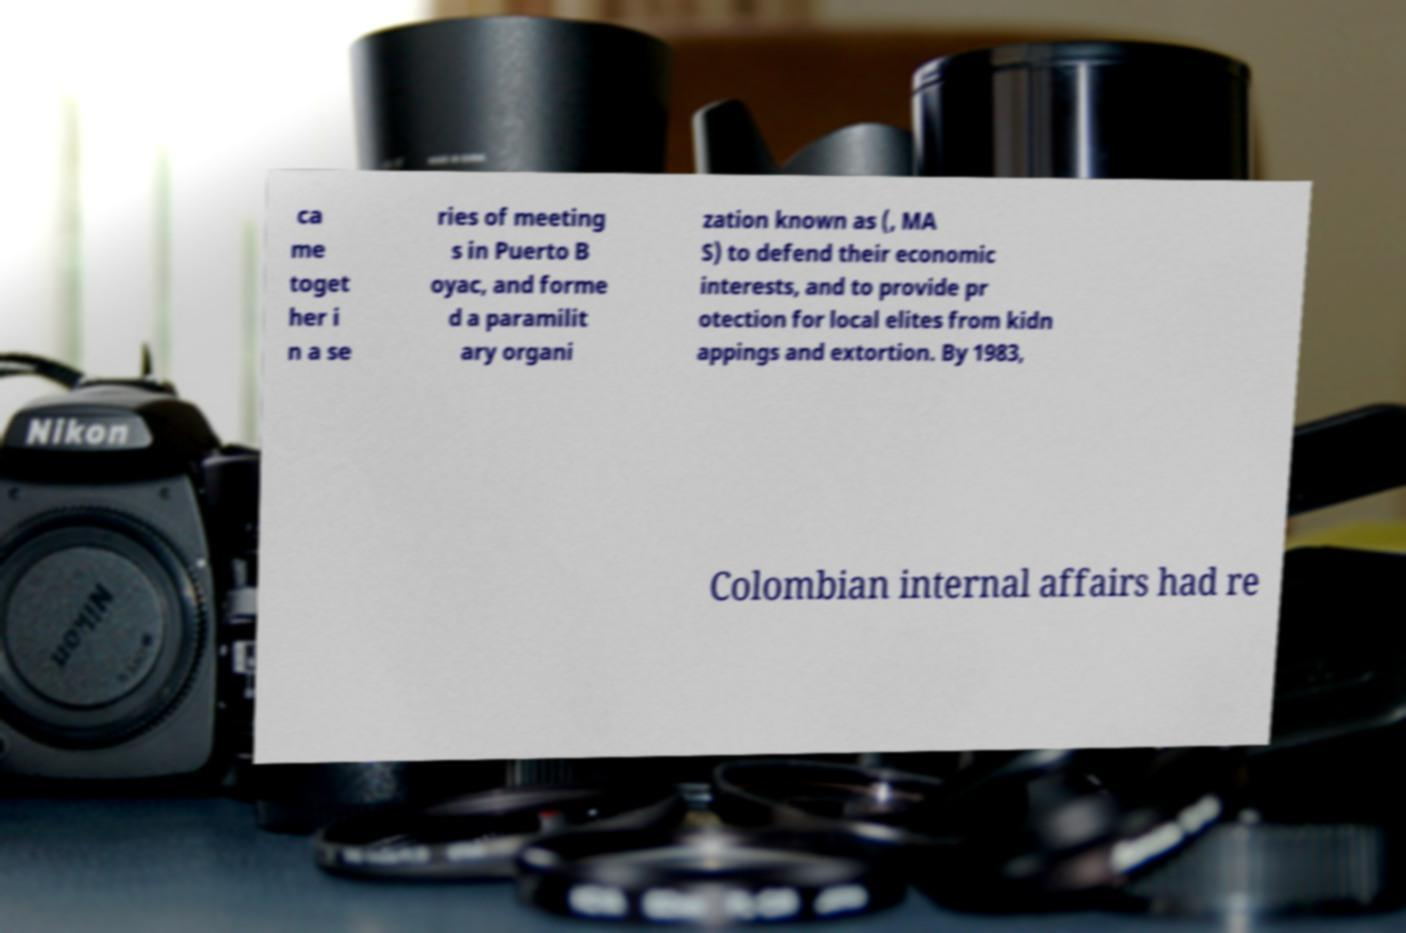Can you accurately transcribe the text from the provided image for me? ca me toget her i n a se ries of meeting s in Puerto B oyac, and forme d a paramilit ary organi zation known as (, MA S) to defend their economic interests, and to provide pr otection for local elites from kidn appings and extortion. By 1983, Colombian internal affairs had re 